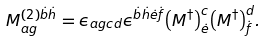<formula> <loc_0><loc_0><loc_500><loc_500>M _ { a g } ^ { ( 2 ) \dot { b } \dot { h } } = \epsilon _ { a g c d } \epsilon ^ { \dot { b } \dot { h } \dot { e } \dot { f } } { \left ( M ^ { \dagger } \right ) } _ { \dot { e } } ^ { c } { \left ( M ^ { \dagger } \right ) } _ { \dot { f } } ^ { d } .</formula> 